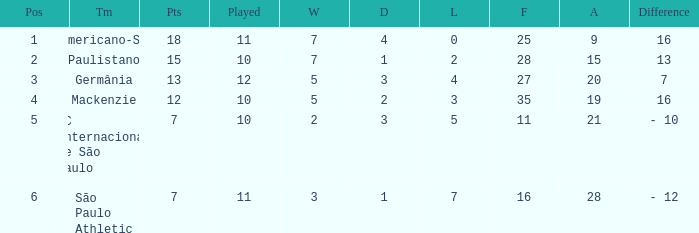Name the least for when played is 12 27.0. 